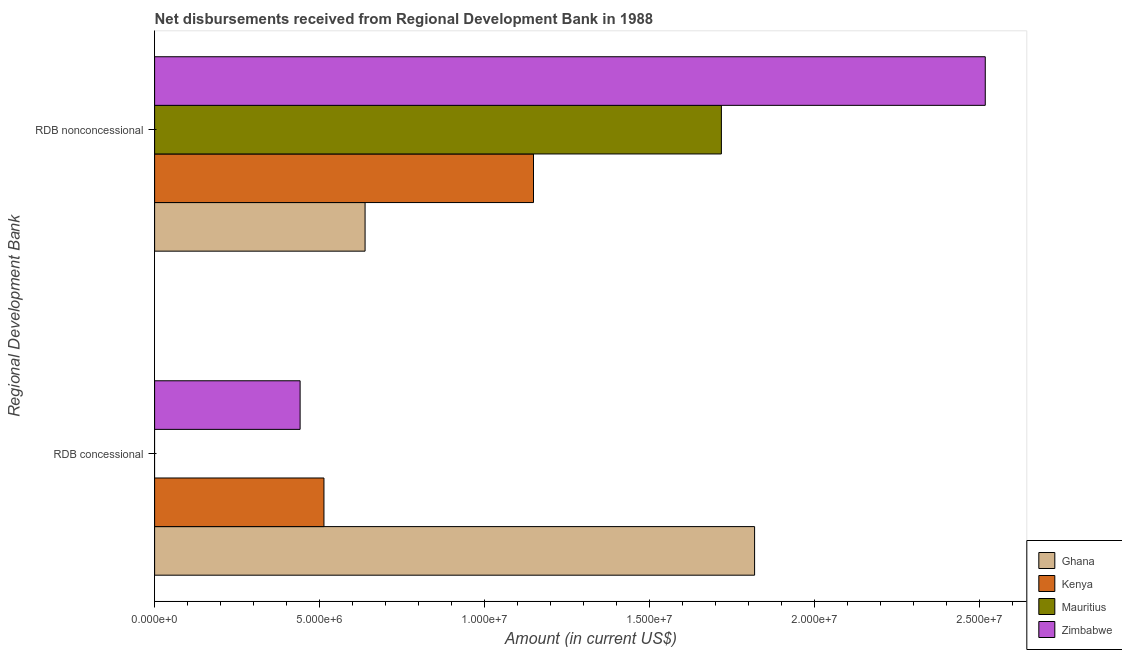Are the number of bars per tick equal to the number of legend labels?
Keep it short and to the point. No. How many bars are there on the 2nd tick from the top?
Make the answer very short. 3. How many bars are there on the 2nd tick from the bottom?
Ensure brevity in your answer.  4. What is the label of the 1st group of bars from the top?
Provide a succinct answer. RDB nonconcessional. What is the net concessional disbursements from rdb in Ghana?
Give a very brief answer. 1.82e+07. Across all countries, what is the maximum net concessional disbursements from rdb?
Your response must be concise. 1.82e+07. Across all countries, what is the minimum net concessional disbursements from rdb?
Offer a terse response. 0. In which country was the net non concessional disbursements from rdb maximum?
Give a very brief answer. Zimbabwe. What is the total net concessional disbursements from rdb in the graph?
Your answer should be very brief. 2.77e+07. What is the difference between the net non concessional disbursements from rdb in Zimbabwe and that in Kenya?
Your answer should be compact. 1.37e+07. What is the difference between the net concessional disbursements from rdb in Zimbabwe and the net non concessional disbursements from rdb in Ghana?
Provide a succinct answer. -1.97e+06. What is the average net concessional disbursements from rdb per country?
Your answer should be very brief. 6.93e+06. What is the difference between the net non concessional disbursements from rdb and net concessional disbursements from rdb in Ghana?
Provide a succinct answer. -1.18e+07. In how many countries, is the net concessional disbursements from rdb greater than 16000000 US$?
Your response must be concise. 1. What is the ratio of the net non concessional disbursements from rdb in Ghana to that in Mauritius?
Keep it short and to the point. 0.37. Is the net non concessional disbursements from rdb in Ghana less than that in Zimbabwe?
Your response must be concise. Yes. Are all the bars in the graph horizontal?
Your answer should be compact. Yes. How many countries are there in the graph?
Your response must be concise. 4. What is the difference between two consecutive major ticks on the X-axis?
Offer a terse response. 5.00e+06. Does the graph contain any zero values?
Offer a terse response. Yes. How are the legend labels stacked?
Ensure brevity in your answer.  Vertical. What is the title of the graph?
Offer a terse response. Net disbursements received from Regional Development Bank in 1988. What is the label or title of the X-axis?
Keep it short and to the point. Amount (in current US$). What is the label or title of the Y-axis?
Make the answer very short. Regional Development Bank. What is the Amount (in current US$) of Ghana in RDB concessional?
Your answer should be very brief. 1.82e+07. What is the Amount (in current US$) of Kenya in RDB concessional?
Your answer should be compact. 5.13e+06. What is the Amount (in current US$) of Mauritius in RDB concessional?
Offer a very short reply. 0. What is the Amount (in current US$) in Zimbabwe in RDB concessional?
Keep it short and to the point. 4.41e+06. What is the Amount (in current US$) in Ghana in RDB nonconcessional?
Your answer should be compact. 6.38e+06. What is the Amount (in current US$) of Kenya in RDB nonconcessional?
Make the answer very short. 1.15e+07. What is the Amount (in current US$) in Mauritius in RDB nonconcessional?
Your response must be concise. 1.72e+07. What is the Amount (in current US$) in Zimbabwe in RDB nonconcessional?
Your answer should be compact. 2.52e+07. Across all Regional Development Bank, what is the maximum Amount (in current US$) in Ghana?
Your answer should be very brief. 1.82e+07. Across all Regional Development Bank, what is the maximum Amount (in current US$) in Kenya?
Offer a very short reply. 1.15e+07. Across all Regional Development Bank, what is the maximum Amount (in current US$) in Mauritius?
Your answer should be compact. 1.72e+07. Across all Regional Development Bank, what is the maximum Amount (in current US$) in Zimbabwe?
Provide a succinct answer. 2.52e+07. Across all Regional Development Bank, what is the minimum Amount (in current US$) of Ghana?
Provide a succinct answer. 6.38e+06. Across all Regional Development Bank, what is the minimum Amount (in current US$) of Kenya?
Offer a terse response. 5.13e+06. Across all Regional Development Bank, what is the minimum Amount (in current US$) in Mauritius?
Ensure brevity in your answer.  0. Across all Regional Development Bank, what is the minimum Amount (in current US$) in Zimbabwe?
Make the answer very short. 4.41e+06. What is the total Amount (in current US$) of Ghana in the graph?
Ensure brevity in your answer.  2.46e+07. What is the total Amount (in current US$) in Kenya in the graph?
Keep it short and to the point. 1.66e+07. What is the total Amount (in current US$) of Mauritius in the graph?
Your response must be concise. 1.72e+07. What is the total Amount (in current US$) of Zimbabwe in the graph?
Give a very brief answer. 2.96e+07. What is the difference between the Amount (in current US$) of Ghana in RDB concessional and that in RDB nonconcessional?
Keep it short and to the point. 1.18e+07. What is the difference between the Amount (in current US$) in Kenya in RDB concessional and that in RDB nonconcessional?
Your response must be concise. -6.35e+06. What is the difference between the Amount (in current US$) of Zimbabwe in RDB concessional and that in RDB nonconcessional?
Offer a terse response. -2.08e+07. What is the difference between the Amount (in current US$) of Ghana in RDB concessional and the Amount (in current US$) of Kenya in RDB nonconcessional?
Your response must be concise. 6.70e+06. What is the difference between the Amount (in current US$) in Ghana in RDB concessional and the Amount (in current US$) in Mauritius in RDB nonconcessional?
Provide a short and direct response. 1.01e+06. What is the difference between the Amount (in current US$) of Ghana in RDB concessional and the Amount (in current US$) of Zimbabwe in RDB nonconcessional?
Keep it short and to the point. -6.99e+06. What is the difference between the Amount (in current US$) of Kenya in RDB concessional and the Amount (in current US$) of Mauritius in RDB nonconcessional?
Offer a terse response. -1.20e+07. What is the difference between the Amount (in current US$) in Kenya in RDB concessional and the Amount (in current US$) in Zimbabwe in RDB nonconcessional?
Keep it short and to the point. -2.00e+07. What is the average Amount (in current US$) of Ghana per Regional Development Bank?
Your response must be concise. 1.23e+07. What is the average Amount (in current US$) in Kenya per Regional Development Bank?
Provide a succinct answer. 8.30e+06. What is the average Amount (in current US$) of Mauritius per Regional Development Bank?
Ensure brevity in your answer.  8.58e+06. What is the average Amount (in current US$) in Zimbabwe per Regional Development Bank?
Provide a short and direct response. 1.48e+07. What is the difference between the Amount (in current US$) in Ghana and Amount (in current US$) in Kenya in RDB concessional?
Your answer should be very brief. 1.30e+07. What is the difference between the Amount (in current US$) of Ghana and Amount (in current US$) of Zimbabwe in RDB concessional?
Keep it short and to the point. 1.38e+07. What is the difference between the Amount (in current US$) of Kenya and Amount (in current US$) of Zimbabwe in RDB concessional?
Your answer should be compact. 7.22e+05. What is the difference between the Amount (in current US$) of Ghana and Amount (in current US$) of Kenya in RDB nonconcessional?
Offer a very short reply. -5.10e+06. What is the difference between the Amount (in current US$) in Ghana and Amount (in current US$) in Mauritius in RDB nonconcessional?
Your answer should be very brief. -1.08e+07. What is the difference between the Amount (in current US$) in Ghana and Amount (in current US$) in Zimbabwe in RDB nonconcessional?
Give a very brief answer. -1.88e+07. What is the difference between the Amount (in current US$) of Kenya and Amount (in current US$) of Mauritius in RDB nonconcessional?
Keep it short and to the point. -5.69e+06. What is the difference between the Amount (in current US$) of Kenya and Amount (in current US$) of Zimbabwe in RDB nonconcessional?
Provide a short and direct response. -1.37e+07. What is the difference between the Amount (in current US$) in Mauritius and Amount (in current US$) in Zimbabwe in RDB nonconcessional?
Make the answer very short. -7.99e+06. What is the ratio of the Amount (in current US$) in Ghana in RDB concessional to that in RDB nonconcessional?
Your answer should be compact. 2.85. What is the ratio of the Amount (in current US$) of Kenya in RDB concessional to that in RDB nonconcessional?
Give a very brief answer. 0.45. What is the ratio of the Amount (in current US$) in Zimbabwe in RDB concessional to that in RDB nonconcessional?
Make the answer very short. 0.18. What is the difference between the highest and the second highest Amount (in current US$) in Ghana?
Your response must be concise. 1.18e+07. What is the difference between the highest and the second highest Amount (in current US$) in Kenya?
Offer a terse response. 6.35e+06. What is the difference between the highest and the second highest Amount (in current US$) in Zimbabwe?
Give a very brief answer. 2.08e+07. What is the difference between the highest and the lowest Amount (in current US$) of Ghana?
Provide a short and direct response. 1.18e+07. What is the difference between the highest and the lowest Amount (in current US$) of Kenya?
Ensure brevity in your answer.  6.35e+06. What is the difference between the highest and the lowest Amount (in current US$) in Mauritius?
Your answer should be very brief. 1.72e+07. What is the difference between the highest and the lowest Amount (in current US$) of Zimbabwe?
Offer a very short reply. 2.08e+07. 